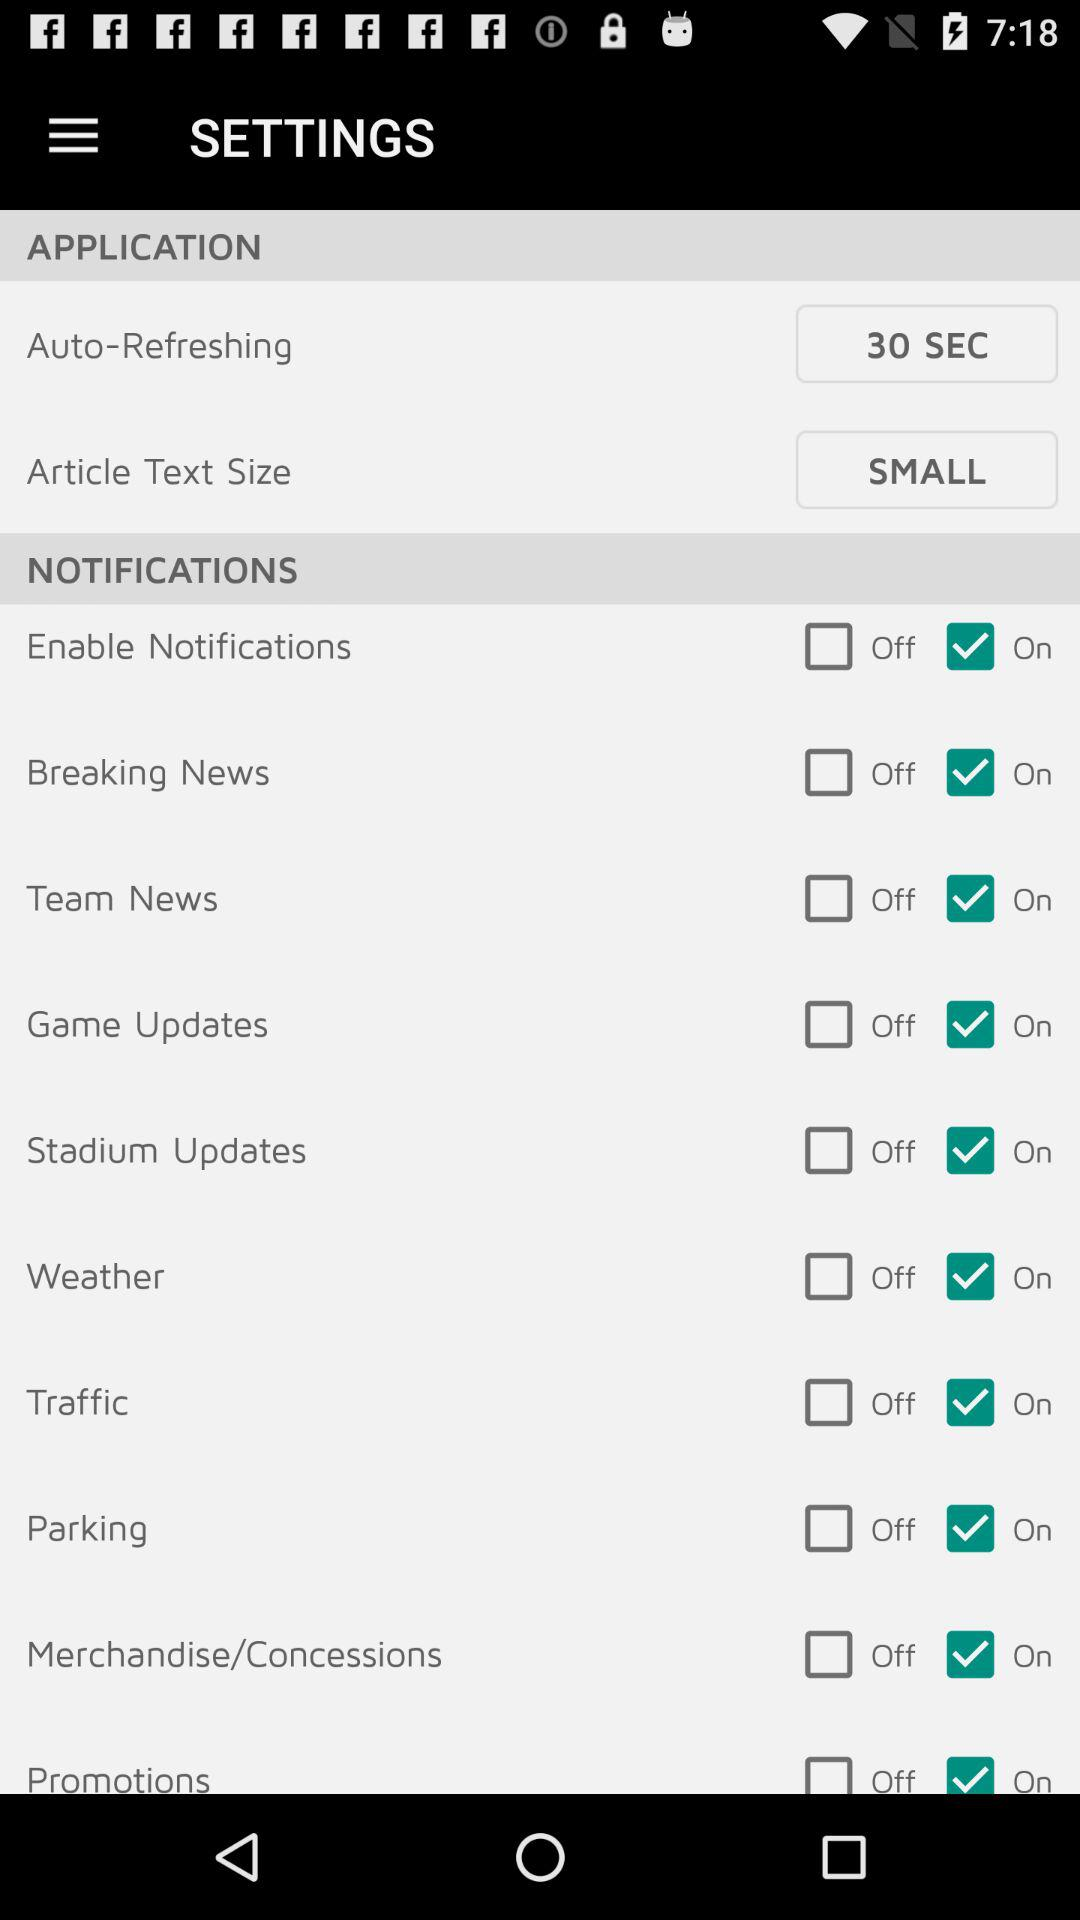What's the status of game updates? The status is "on". 